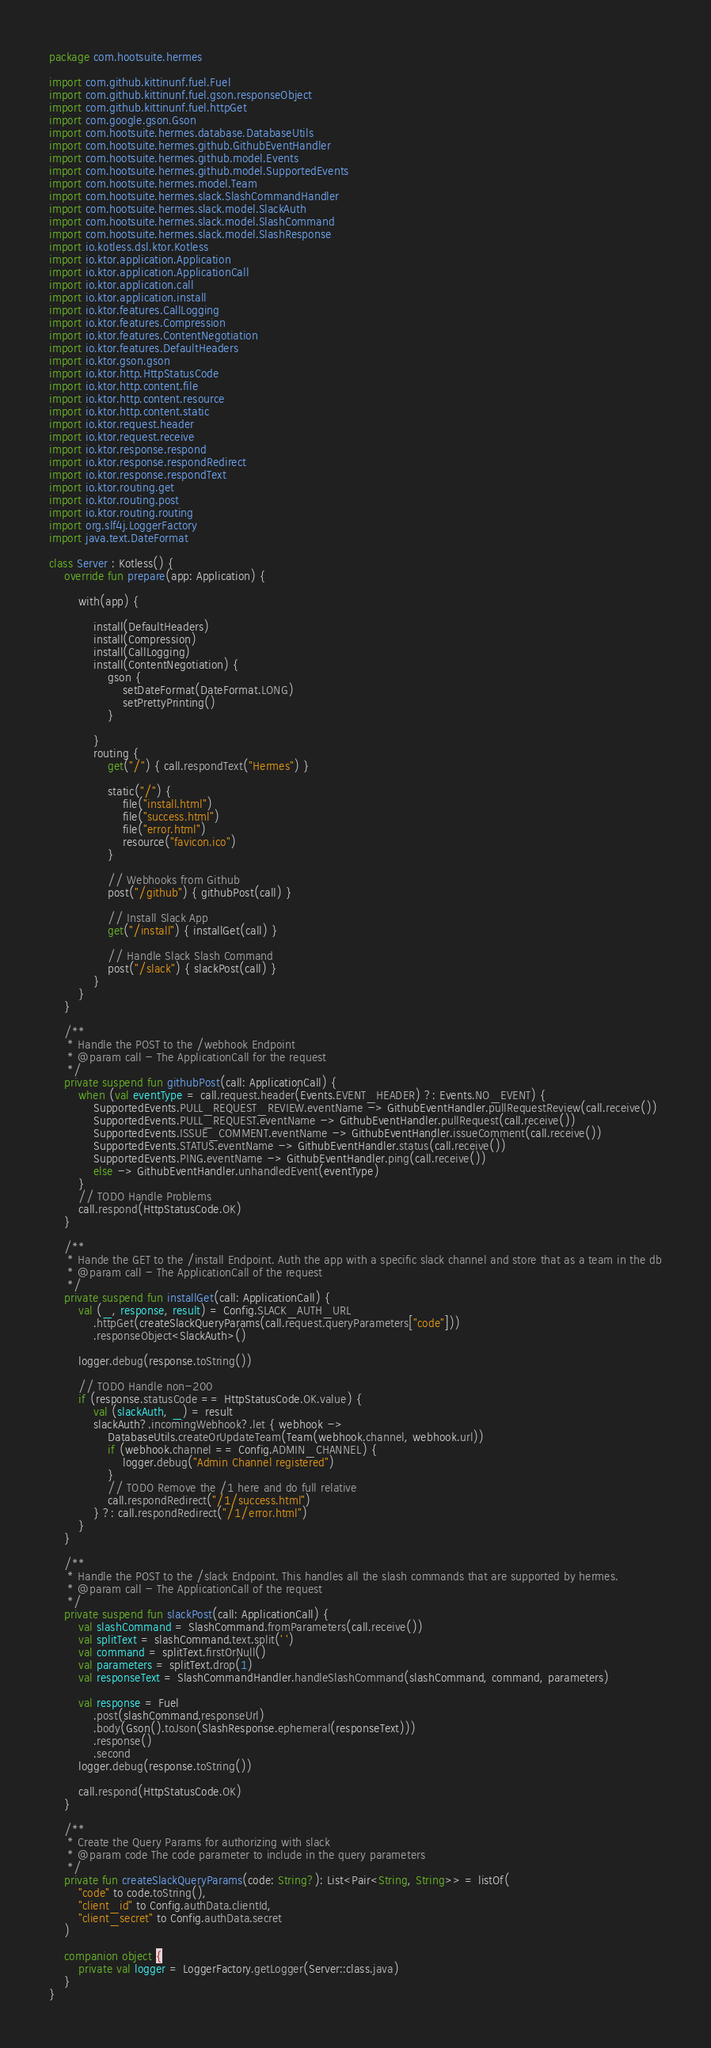<code> <loc_0><loc_0><loc_500><loc_500><_Kotlin_>package com.hootsuite.hermes

import com.github.kittinunf.fuel.Fuel
import com.github.kittinunf.fuel.gson.responseObject
import com.github.kittinunf.fuel.httpGet
import com.google.gson.Gson
import com.hootsuite.hermes.database.DatabaseUtils
import com.hootsuite.hermes.github.GithubEventHandler
import com.hootsuite.hermes.github.model.Events
import com.hootsuite.hermes.github.model.SupportedEvents
import com.hootsuite.hermes.model.Team
import com.hootsuite.hermes.slack.SlashCommandHandler
import com.hootsuite.hermes.slack.model.SlackAuth
import com.hootsuite.hermes.slack.model.SlashCommand
import com.hootsuite.hermes.slack.model.SlashResponse
import io.kotless.dsl.ktor.Kotless
import io.ktor.application.Application
import io.ktor.application.ApplicationCall
import io.ktor.application.call
import io.ktor.application.install
import io.ktor.features.CallLogging
import io.ktor.features.Compression
import io.ktor.features.ContentNegotiation
import io.ktor.features.DefaultHeaders
import io.ktor.gson.gson
import io.ktor.http.HttpStatusCode
import io.ktor.http.content.file
import io.ktor.http.content.resource
import io.ktor.http.content.static
import io.ktor.request.header
import io.ktor.request.receive
import io.ktor.response.respond
import io.ktor.response.respondRedirect
import io.ktor.response.respondText
import io.ktor.routing.get
import io.ktor.routing.post
import io.ktor.routing.routing
import org.slf4j.LoggerFactory
import java.text.DateFormat

class Server : Kotless() {
    override fun prepare(app: Application) {

        with(app) {

            install(DefaultHeaders)
            install(Compression)
            install(CallLogging)
            install(ContentNegotiation) {
                gson {
                    setDateFormat(DateFormat.LONG)
                    setPrettyPrinting()
                }

            }
            routing {
                get("/") { call.respondText("Hermes") }

                static("/") {
                    file("install.html")
                    file("success.html")
                    file("error.html")
                    resource("favicon.ico")
                }

                // Webhooks from Github
                post("/github") { githubPost(call) }

                // Install Slack App
                get("/install") { installGet(call) }

                // Handle Slack Slash Command
                post("/slack") { slackPost(call) }
            }
        }
    }

    /**
     * Handle the POST to the /webhook Endpoint
     * @param call - The ApplicationCall for the request
     */
    private suspend fun githubPost(call: ApplicationCall) {
        when (val eventType = call.request.header(Events.EVENT_HEADER) ?: Events.NO_EVENT) {
            SupportedEvents.PULL_REQUEST_REVIEW.eventName -> GithubEventHandler.pullRequestReview(call.receive())
            SupportedEvents.PULL_REQUEST.eventName -> GithubEventHandler.pullRequest(call.receive())
            SupportedEvents.ISSUE_COMMENT.eventName -> GithubEventHandler.issueComment(call.receive())
            SupportedEvents.STATUS.eventName -> GithubEventHandler.status(call.receive())
            SupportedEvents.PING.eventName -> GithubEventHandler.ping(call.receive())
            else -> GithubEventHandler.unhandledEvent(eventType)
        }
        // TODO Handle Problems
        call.respond(HttpStatusCode.OK)
    }

    /**
     * Hande the GET to the /install Endpoint. Auth the app with a specific slack channel and store that as a team in the db
     * @param call - The ApplicationCall of the request
     */
    private suspend fun installGet(call: ApplicationCall) {
        val (_, response, result) = Config.SLACK_AUTH_URL
            .httpGet(createSlackQueryParams(call.request.queryParameters["code"]))
            .responseObject<SlackAuth>()

        logger.debug(response.toString())

        // TODO Handle non-200
        if (response.statusCode == HttpStatusCode.OK.value) {
            val (slackAuth, _) = result
            slackAuth?.incomingWebhook?.let { webhook ->
                DatabaseUtils.createOrUpdateTeam(Team(webhook.channel, webhook.url))
                if (webhook.channel == Config.ADMIN_CHANNEL) {
                    logger.debug("Admin Channel registered")
                }
                // TODO Remove the /1 here and do full relative
                call.respondRedirect("/1/success.html")
            } ?: call.respondRedirect("/1/error.html")
        }
    }

    /**
     * Handle the POST to the /slack Endpoint. This handles all the slash commands that are supported by hermes.
     * @param call - The ApplicationCall of the request
     */
    private suspend fun slackPost(call: ApplicationCall) {
        val slashCommand = SlashCommand.fromParameters(call.receive())
        val splitText = slashCommand.text.split(' ')
        val command = splitText.firstOrNull()
        val parameters = splitText.drop(1)
        val responseText = SlashCommandHandler.handleSlashCommand(slashCommand, command, parameters)

        val response = Fuel
            .post(slashCommand.responseUrl)
            .body(Gson().toJson(SlashResponse.ephemeral(responseText)))
            .response()
            .second
        logger.debug(response.toString())

        call.respond(HttpStatusCode.OK)
    }

    /**
     * Create the Query Params for authorizing with slack
     * @param code The code parameter to include in the query parameters
     */
    private fun createSlackQueryParams(code: String?): List<Pair<String, String>> = listOf(
        "code" to code.toString(),
        "client_id" to Config.authData.clientId,
        "client_secret" to Config.authData.secret
    )

    companion object {
        private val logger = LoggerFactory.getLogger(Server::class.java)
    }
}
</code> 